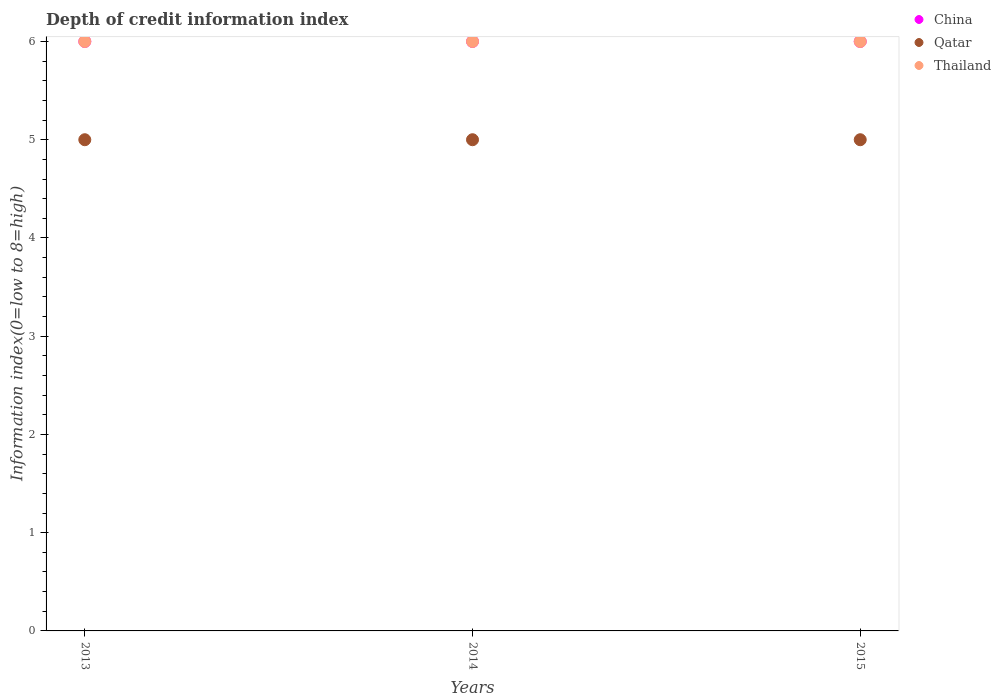Across all years, what is the maximum information index in Qatar?
Provide a succinct answer. 5. In which year was the information index in Qatar minimum?
Your response must be concise. 2013. What is the total information index in Thailand in the graph?
Provide a short and direct response. 18. What is the difference between the information index in Thailand in 2013 and that in 2015?
Keep it short and to the point. 0. What is the difference between the information index in Thailand in 2013 and the information index in Qatar in 2014?
Keep it short and to the point. 1. In the year 2013, what is the difference between the information index in Thailand and information index in China?
Your answer should be compact. 0. In how many years, is the information index in Qatar greater than 0.2?
Your answer should be very brief. 3. What is the ratio of the information index in Thailand in 2014 to that in 2015?
Keep it short and to the point. 1. Is the difference between the information index in Thailand in 2014 and 2015 greater than the difference between the information index in China in 2014 and 2015?
Your answer should be very brief. No. What is the difference between the highest and the second highest information index in Qatar?
Keep it short and to the point. 0. What is the difference between the highest and the lowest information index in China?
Your answer should be very brief. 0. Is the information index in Thailand strictly greater than the information index in Qatar over the years?
Give a very brief answer. Yes. How many dotlines are there?
Your response must be concise. 3. How many years are there in the graph?
Your answer should be compact. 3. What is the difference between two consecutive major ticks on the Y-axis?
Offer a very short reply. 1. Does the graph contain any zero values?
Keep it short and to the point. No. Where does the legend appear in the graph?
Provide a succinct answer. Top right. How many legend labels are there?
Your response must be concise. 3. How are the legend labels stacked?
Your answer should be compact. Vertical. What is the title of the graph?
Your answer should be very brief. Depth of credit information index. Does "Netherlands" appear as one of the legend labels in the graph?
Provide a succinct answer. No. What is the label or title of the X-axis?
Offer a very short reply. Years. What is the label or title of the Y-axis?
Ensure brevity in your answer.  Information index(0=low to 8=high). What is the Information index(0=low to 8=high) in China in 2014?
Offer a terse response. 6. What is the Information index(0=low to 8=high) of Thailand in 2014?
Provide a succinct answer. 6. What is the Information index(0=low to 8=high) in China in 2015?
Your answer should be compact. 6. What is the Information index(0=low to 8=high) in Qatar in 2015?
Your response must be concise. 5. What is the Information index(0=low to 8=high) of Thailand in 2015?
Ensure brevity in your answer.  6. Across all years, what is the maximum Information index(0=low to 8=high) in Qatar?
Your answer should be compact. 5. Across all years, what is the minimum Information index(0=low to 8=high) in China?
Make the answer very short. 6. Across all years, what is the minimum Information index(0=low to 8=high) of Thailand?
Make the answer very short. 6. What is the difference between the Information index(0=low to 8=high) of China in 2013 and that in 2014?
Give a very brief answer. 0. What is the difference between the Information index(0=low to 8=high) of Qatar in 2013 and that in 2014?
Your answer should be very brief. 0. What is the difference between the Information index(0=low to 8=high) in Thailand in 2013 and that in 2015?
Give a very brief answer. 0. What is the difference between the Information index(0=low to 8=high) in China in 2014 and that in 2015?
Provide a short and direct response. 0. What is the difference between the Information index(0=low to 8=high) of Qatar in 2014 and that in 2015?
Keep it short and to the point. 0. What is the difference between the Information index(0=low to 8=high) of Thailand in 2014 and that in 2015?
Make the answer very short. 0. What is the difference between the Information index(0=low to 8=high) of China in 2013 and the Information index(0=low to 8=high) of Qatar in 2014?
Provide a succinct answer. 1. What is the difference between the Information index(0=low to 8=high) of Qatar in 2013 and the Information index(0=low to 8=high) of Thailand in 2014?
Your response must be concise. -1. What is the difference between the Information index(0=low to 8=high) of China in 2013 and the Information index(0=low to 8=high) of Qatar in 2015?
Your answer should be very brief. 1. What is the difference between the Information index(0=low to 8=high) of China in 2013 and the Information index(0=low to 8=high) of Thailand in 2015?
Offer a terse response. 0. What is the average Information index(0=low to 8=high) of China per year?
Offer a very short reply. 6. What is the average Information index(0=low to 8=high) in Qatar per year?
Provide a short and direct response. 5. In the year 2013, what is the difference between the Information index(0=low to 8=high) of China and Information index(0=low to 8=high) of Thailand?
Provide a short and direct response. 0. In the year 2014, what is the difference between the Information index(0=low to 8=high) of China and Information index(0=low to 8=high) of Thailand?
Make the answer very short. 0. In the year 2014, what is the difference between the Information index(0=low to 8=high) of Qatar and Information index(0=low to 8=high) of Thailand?
Make the answer very short. -1. In the year 2015, what is the difference between the Information index(0=low to 8=high) of Qatar and Information index(0=low to 8=high) of Thailand?
Provide a short and direct response. -1. What is the ratio of the Information index(0=low to 8=high) in Thailand in 2013 to that in 2014?
Give a very brief answer. 1. What is the ratio of the Information index(0=low to 8=high) of Thailand in 2013 to that in 2015?
Your answer should be very brief. 1. What is the ratio of the Information index(0=low to 8=high) of China in 2014 to that in 2015?
Ensure brevity in your answer.  1. What is the ratio of the Information index(0=low to 8=high) of Qatar in 2014 to that in 2015?
Keep it short and to the point. 1. What is the difference between the highest and the second highest Information index(0=low to 8=high) in Qatar?
Offer a terse response. 0. What is the difference between the highest and the lowest Information index(0=low to 8=high) of China?
Make the answer very short. 0. What is the difference between the highest and the lowest Information index(0=low to 8=high) of Qatar?
Offer a terse response. 0. What is the difference between the highest and the lowest Information index(0=low to 8=high) of Thailand?
Provide a short and direct response. 0. 